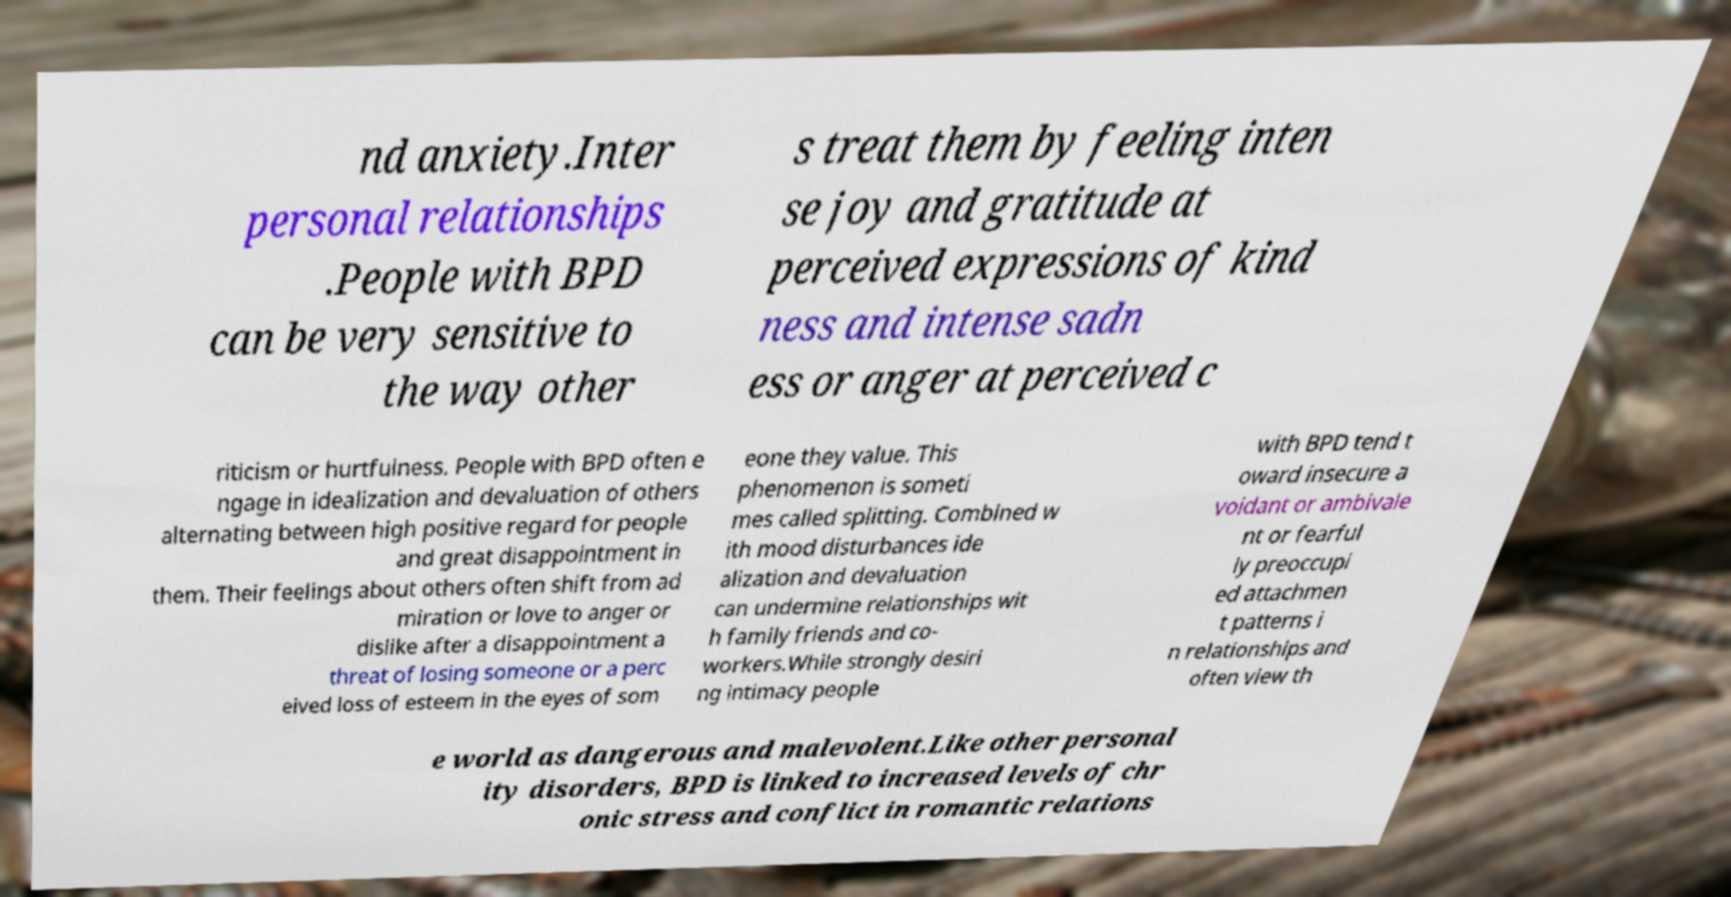There's text embedded in this image that I need extracted. Can you transcribe it verbatim? nd anxiety.Inter personal relationships .People with BPD can be very sensitive to the way other s treat them by feeling inten se joy and gratitude at perceived expressions of kind ness and intense sadn ess or anger at perceived c riticism or hurtfulness. People with BPD often e ngage in idealization and devaluation of others alternating between high positive regard for people and great disappointment in them. Their feelings about others often shift from ad miration or love to anger or dislike after a disappointment a threat of losing someone or a perc eived loss of esteem in the eyes of som eone they value. This phenomenon is someti mes called splitting. Combined w ith mood disturbances ide alization and devaluation can undermine relationships wit h family friends and co- workers.While strongly desiri ng intimacy people with BPD tend t oward insecure a voidant or ambivale nt or fearful ly preoccupi ed attachmen t patterns i n relationships and often view th e world as dangerous and malevolent.Like other personal ity disorders, BPD is linked to increased levels of chr onic stress and conflict in romantic relations 